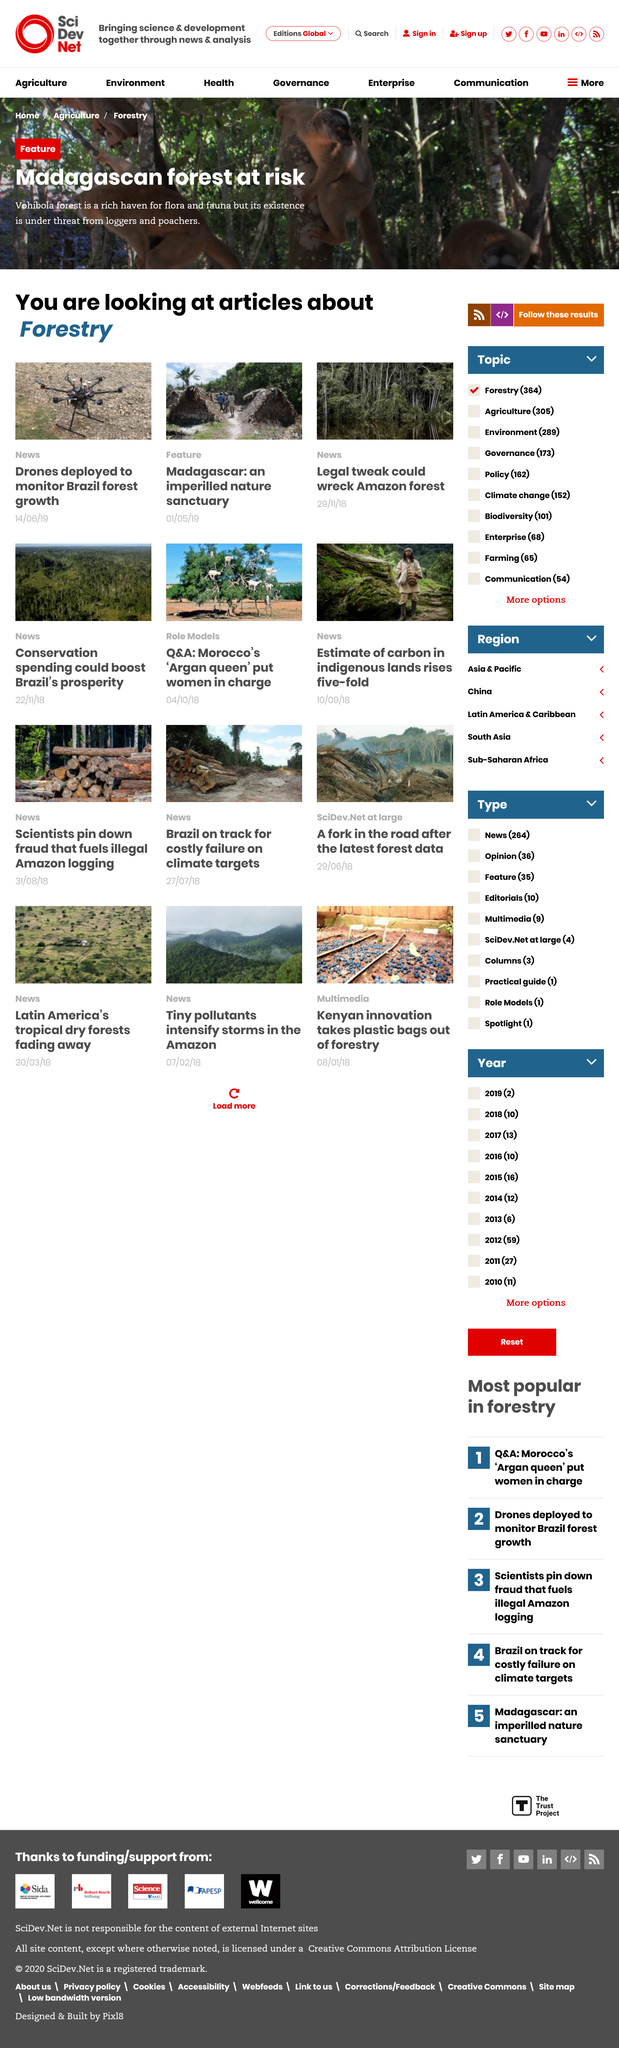Mention a couple of crucial points in this snapshot. The existence of Vohibola forest is under threat from both loggers and poachers, who pose a significant risk to the ecosystem and the animals that call it home. The articles are about forestry. Drones have been deployed to monitor the growth of forests in Brazil. 